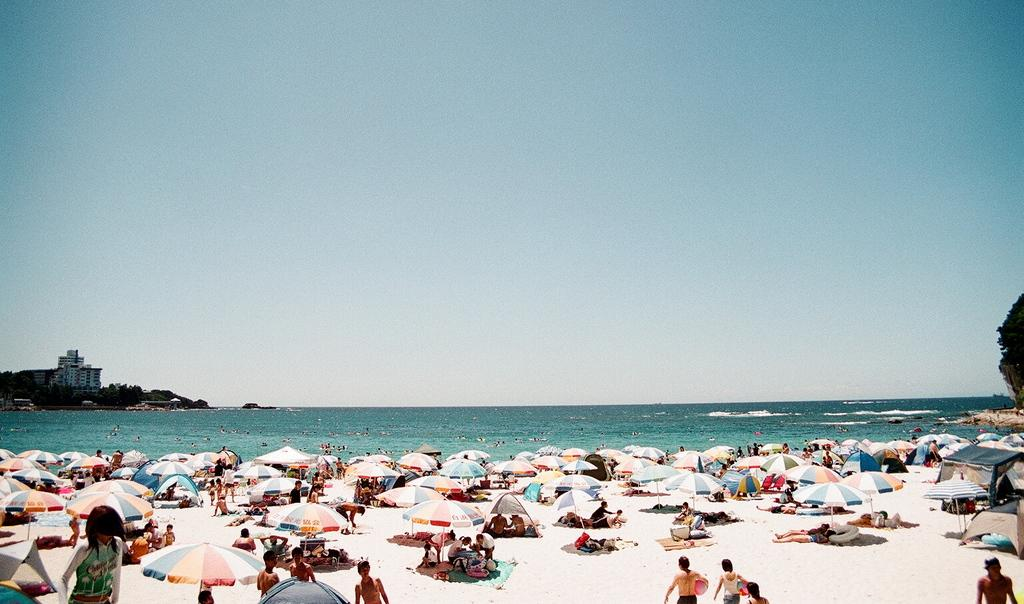What objects are present in the image that provide shade? There are parasols in the image that provide shade. Who or what can be seen in the image? There are people in the image. What can be seen in the distance in the image? There is water, trees, buildings, and the sky visible in the background of the image. What letters are visible on the edge of the water in the image? There are no letters visible on the edge of the water in the image. How does the health of the trees in the image affect the people in the image? The health of the trees in the image is not mentioned, and therefore it cannot be determined how it affects the people in the image. 